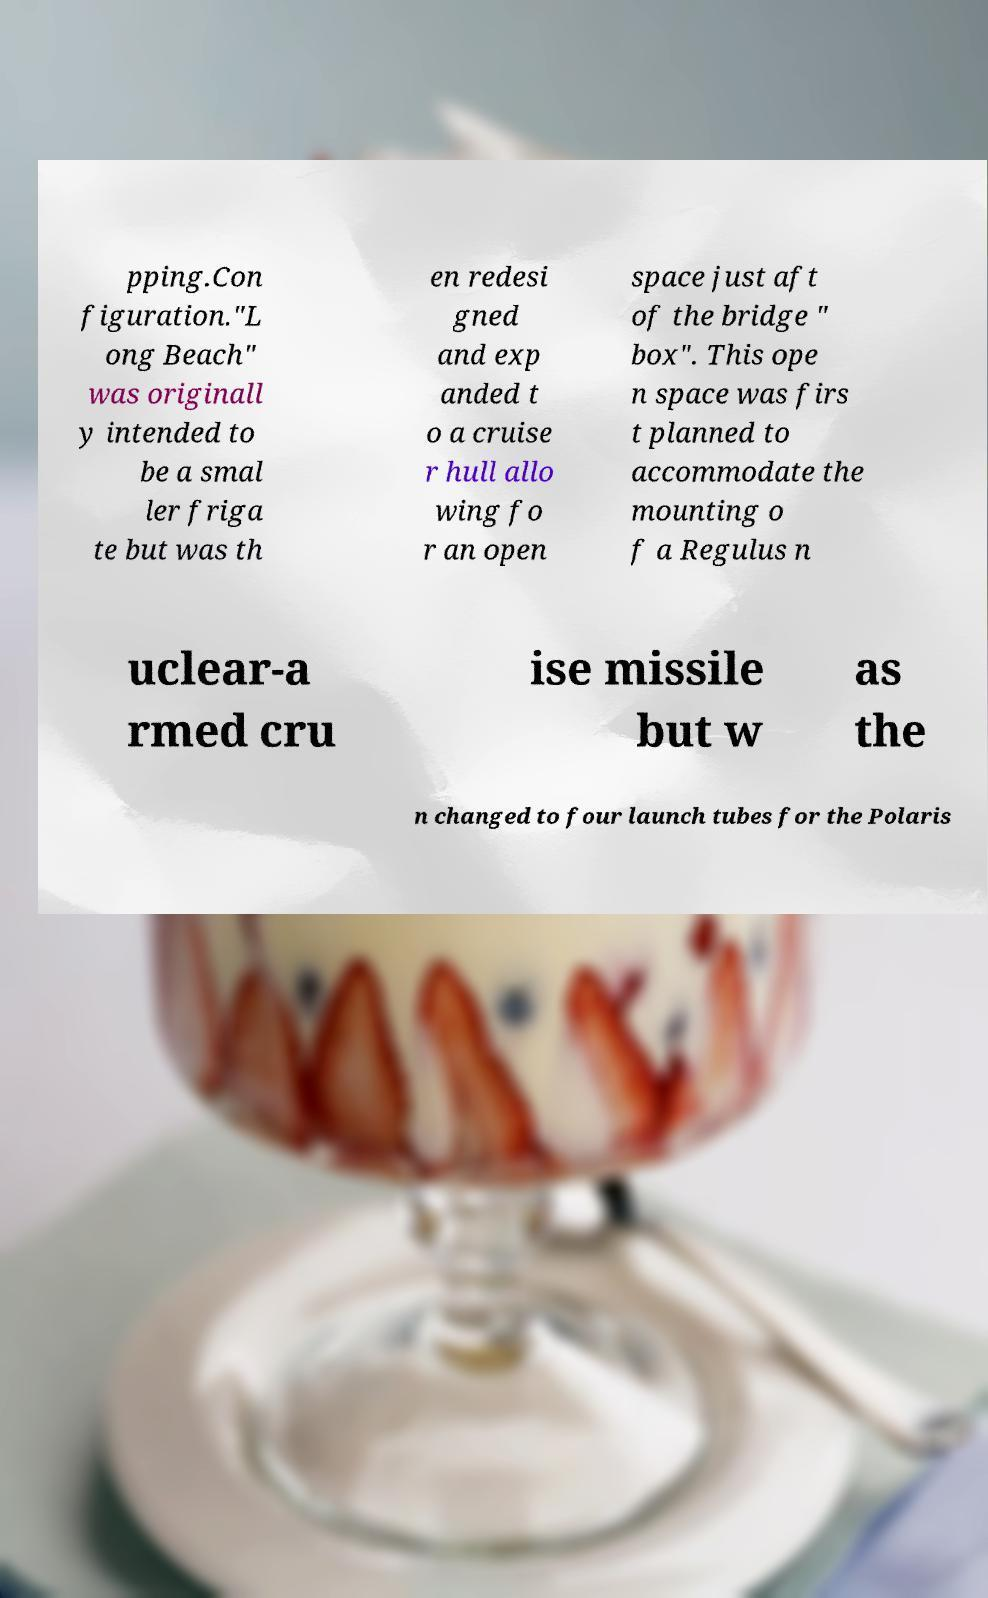What messages or text are displayed in this image? I need them in a readable, typed format. pping.Con figuration."L ong Beach" was originall y intended to be a smal ler friga te but was th en redesi gned and exp anded t o a cruise r hull allo wing fo r an open space just aft of the bridge " box". This ope n space was firs t planned to accommodate the mounting o f a Regulus n uclear-a rmed cru ise missile but w as the n changed to four launch tubes for the Polaris 